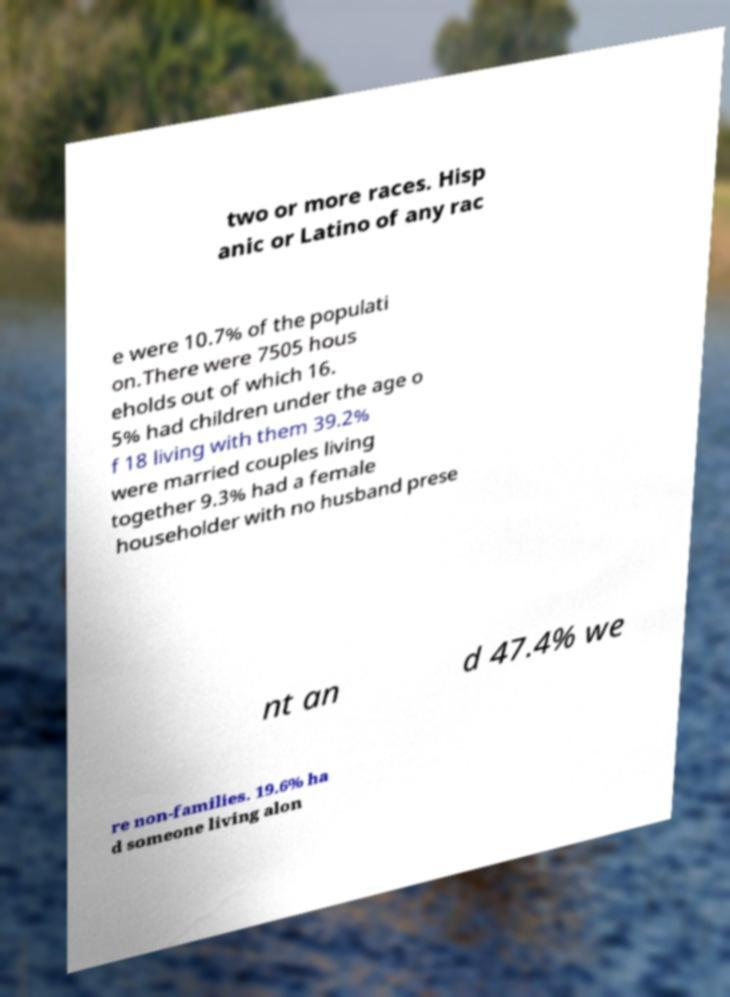Please identify and transcribe the text found in this image. two or more races. Hisp anic or Latino of any rac e were 10.7% of the populati on.There were 7505 hous eholds out of which 16. 5% had children under the age o f 18 living with them 39.2% were married couples living together 9.3% had a female householder with no husband prese nt an d 47.4% we re non-families. 19.6% ha d someone living alon 